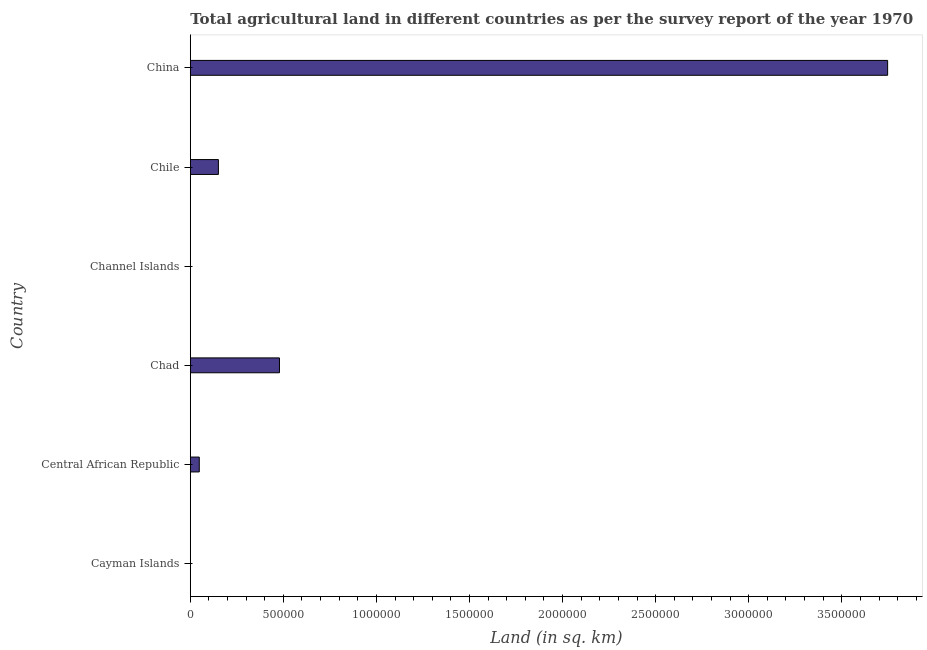Does the graph contain any zero values?
Provide a short and direct response. No. What is the title of the graph?
Offer a terse response. Total agricultural land in different countries as per the survey report of the year 1970. What is the label or title of the X-axis?
Your response must be concise. Land (in sq. km). What is the label or title of the Y-axis?
Give a very brief answer. Country. What is the agricultural land in China?
Keep it short and to the point. 3.75e+06. Across all countries, what is the maximum agricultural land?
Give a very brief answer. 3.75e+06. In which country was the agricultural land maximum?
Offer a terse response. China. In which country was the agricultural land minimum?
Your answer should be compact. Cayman Islands. What is the sum of the agricultural land?
Make the answer very short. 4.42e+06. What is the difference between the agricultural land in Chad and Channel Islands?
Keep it short and to the point. 4.79e+05. What is the average agricultural land per country?
Your answer should be very brief. 7.37e+05. What is the median agricultural land?
Offer a terse response. 9.96e+04. In how many countries, is the agricultural land greater than 1900000 sq. km?
Your answer should be compact. 1. What is the ratio of the agricultural land in Chad to that in Channel Islands?
Your answer should be compact. 5382.02. What is the difference between the highest and the second highest agricultural land?
Offer a very short reply. 3.27e+06. What is the difference between the highest and the lowest agricultural land?
Provide a succinct answer. 3.75e+06. What is the difference between two consecutive major ticks on the X-axis?
Keep it short and to the point. 5.00e+05. What is the Land (in sq. km) in Cayman Islands?
Provide a short and direct response. 27. What is the Land (in sq. km) in Central African Republic?
Keep it short and to the point. 4.83e+04. What is the Land (in sq. km) of Chad?
Provide a short and direct response. 4.79e+05. What is the Land (in sq. km) of Channel Islands?
Provide a short and direct response. 89. What is the Land (in sq. km) in Chile?
Your response must be concise. 1.51e+05. What is the Land (in sq. km) of China?
Offer a terse response. 3.75e+06. What is the difference between the Land (in sq. km) in Cayman Islands and Central African Republic?
Provide a short and direct response. -4.83e+04. What is the difference between the Land (in sq. km) in Cayman Islands and Chad?
Keep it short and to the point. -4.79e+05. What is the difference between the Land (in sq. km) in Cayman Islands and Channel Islands?
Offer a terse response. -62. What is the difference between the Land (in sq. km) in Cayman Islands and Chile?
Your response must be concise. -1.51e+05. What is the difference between the Land (in sq. km) in Cayman Islands and China?
Make the answer very short. -3.75e+06. What is the difference between the Land (in sq. km) in Central African Republic and Chad?
Your response must be concise. -4.31e+05. What is the difference between the Land (in sq. km) in Central African Republic and Channel Islands?
Make the answer very short. 4.82e+04. What is the difference between the Land (in sq. km) in Central African Republic and Chile?
Ensure brevity in your answer.  -1.03e+05. What is the difference between the Land (in sq. km) in Central African Republic and China?
Keep it short and to the point. -3.70e+06. What is the difference between the Land (in sq. km) in Chad and Channel Islands?
Give a very brief answer. 4.79e+05. What is the difference between the Land (in sq. km) in Chad and Chile?
Provide a short and direct response. 3.28e+05. What is the difference between the Land (in sq. km) in Chad and China?
Provide a short and direct response. -3.27e+06. What is the difference between the Land (in sq. km) in Channel Islands and Chile?
Your response must be concise. -1.51e+05. What is the difference between the Land (in sq. km) in Channel Islands and China?
Provide a succinct answer. -3.75e+06. What is the difference between the Land (in sq. km) in Chile and China?
Keep it short and to the point. -3.60e+06. What is the ratio of the Land (in sq. km) in Cayman Islands to that in Chad?
Ensure brevity in your answer.  0. What is the ratio of the Land (in sq. km) in Cayman Islands to that in Channel Islands?
Provide a succinct answer. 0.3. What is the ratio of the Land (in sq. km) in Central African Republic to that in Chad?
Ensure brevity in your answer.  0.1. What is the ratio of the Land (in sq. km) in Central African Republic to that in Channel Islands?
Your answer should be compact. 542.7. What is the ratio of the Land (in sq. km) in Central African Republic to that in Chile?
Make the answer very short. 0.32. What is the ratio of the Land (in sq. km) in Central African Republic to that in China?
Offer a very short reply. 0.01. What is the ratio of the Land (in sq. km) in Chad to that in Channel Islands?
Your answer should be compact. 5382.02. What is the ratio of the Land (in sq. km) in Chad to that in Chile?
Provide a short and direct response. 3.17. What is the ratio of the Land (in sq. km) in Chad to that in China?
Give a very brief answer. 0.13. What is the ratio of the Land (in sq. km) in Channel Islands to that in Chile?
Your response must be concise. 0. 